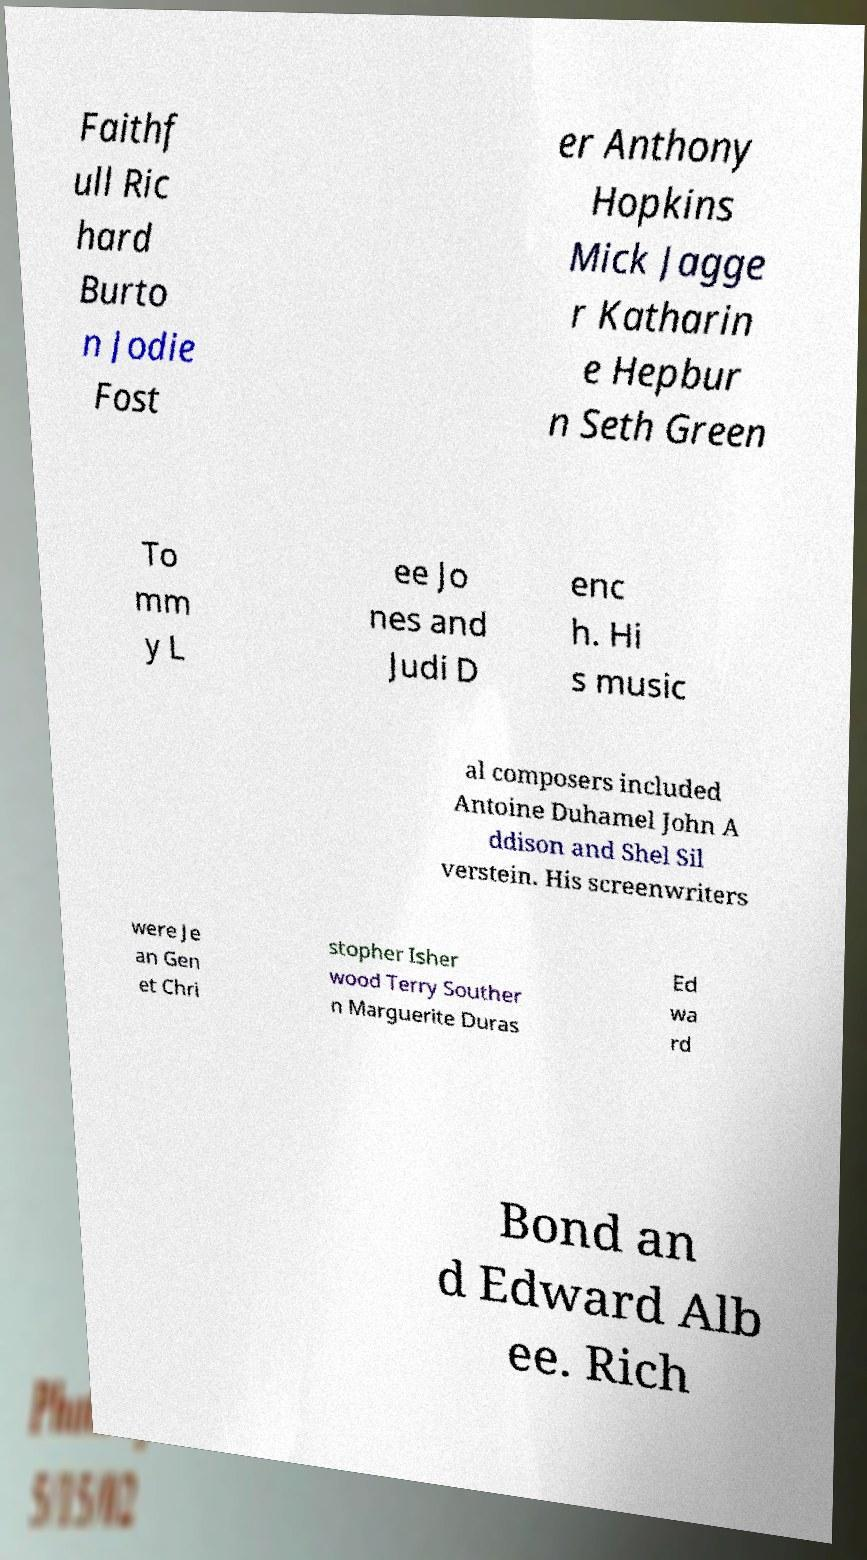Please identify and transcribe the text found in this image. Faithf ull Ric hard Burto n Jodie Fost er Anthony Hopkins Mick Jagge r Katharin e Hepbur n Seth Green To mm y L ee Jo nes and Judi D enc h. Hi s music al composers included Antoine Duhamel John A ddison and Shel Sil verstein. His screenwriters were Je an Gen et Chri stopher Isher wood Terry Souther n Marguerite Duras Ed wa rd Bond an d Edward Alb ee. Rich 